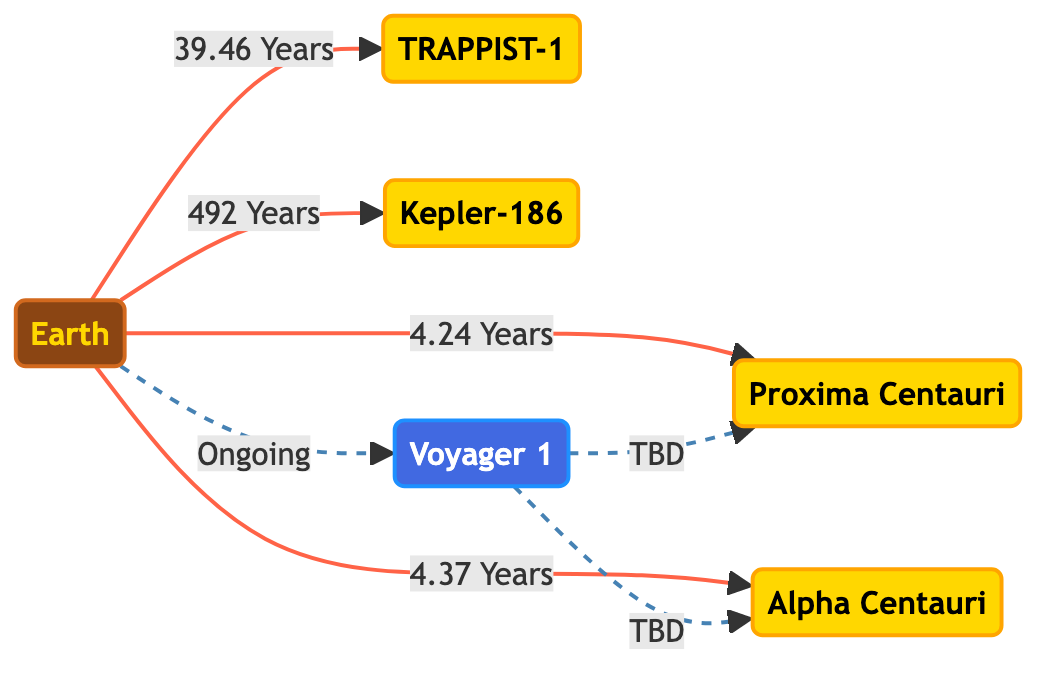What is the distance from Earth to Proxima Centauri? The diagram indicates a direct arrow from Earth to Proxima Centauri with a label showing "4.24 Years". This value represents the duration of communication or signal travel time to Proxima Centauri.
Answer: 4.24 Years How many star systems are shown in the diagram? By counting the labeled stars in the diagram—Proxima Centauri, Alpha Centauri, TRAPPIST-1, and Kepler-186—there are four distinct star systems represented.
Answer: 4 What is the longest signal travel time indicated in the diagram? The diagram shows multiple time labels between Earth and various stars. The longest time is between Earth and Kepler-186, labeled "492 Years".
Answer: 492 Years Which probe is shown in the diagram? In the diagram, the probe is labeled as "Voyager 1", which is specifically highlighted and connects to other nodes with dashed lines indicating ongoing or future communication.
Answer: Voyager 1 Does Voyager 1 have a defined time to reach Proxima Centauri? The diagram shows a dashed line from Voyager 1 to Proxima Centauri labeled "TBD", indicating that the time of arrival or signal travel time to Proxima Centauri has not been determined.
Answer: TBD Which star system is closest to Earth? The diagram illustrates that the shortest signal travel time corresponds to Proxima Centauri with "4.24 Years", indicating it is the closest star system to Earth.
Answer: Proxima Centauri What type of relationship is indicated between Voyager 1 and the other star systems? The relationships from Voyager 1 to Proxima Centauri and Alpha Centauri are represented with dashed lines labeled as "TBD", indicating possible future communication pathways without defined parameters yet.
Answer: Ongoing communication Which star system is furthest from Earth? The diagram indicates the longest travel time to Kepler-186, labeled "492 Years", making it the furthest star system from Earth depicted in the diagram.
Answer: Kepler-186 What connection style is used for the traveling time from Earth to other star systems? The connections from Earth to Proxima Centauri, Alpha Centauri, TRAPPIST-1, and Kepler-186 are solid lines, indicating direct travel time relationships.
Answer: Solid lines 